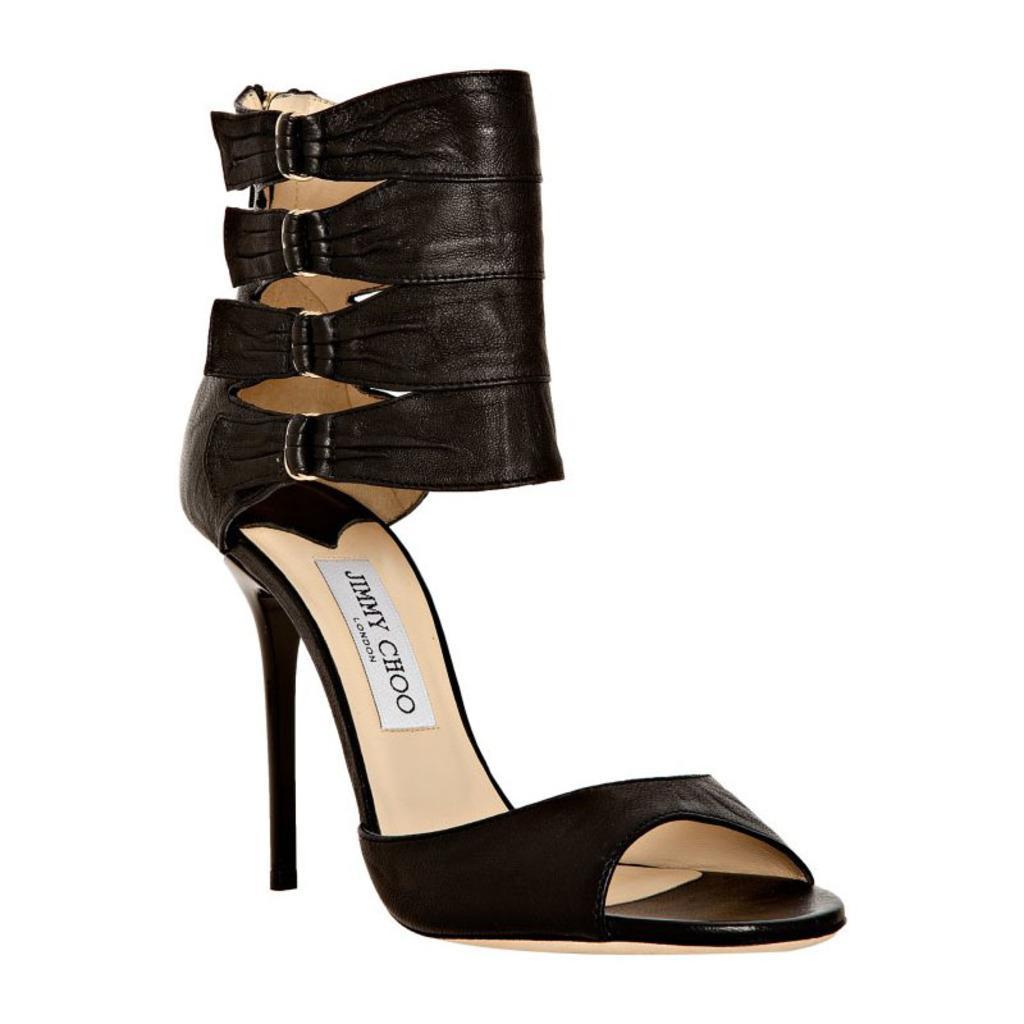Describe this image in one or two sentences. In this picture I can see a women's footwear at is black in color and I can see a white color background. 